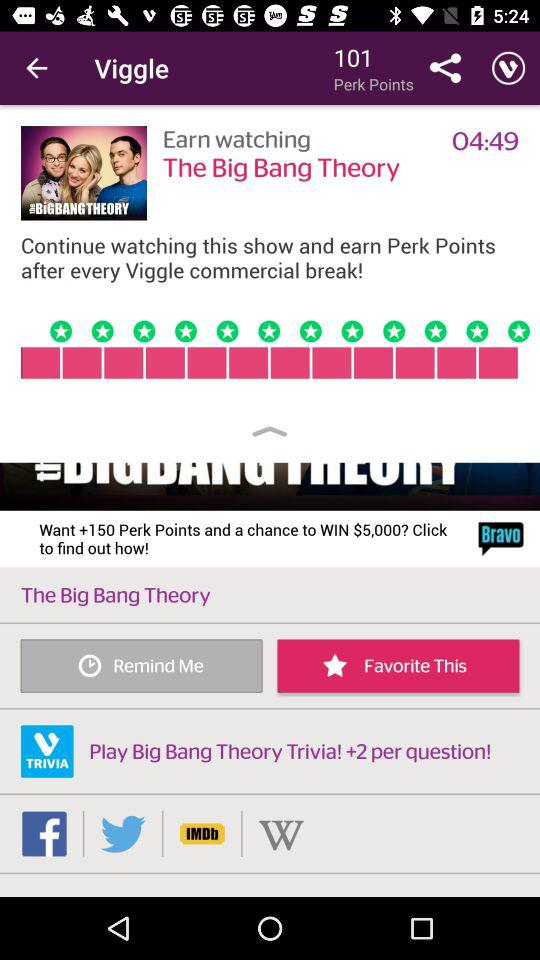How many "Perk Points" are shown on the screen? There are 101 "Perk Points". 